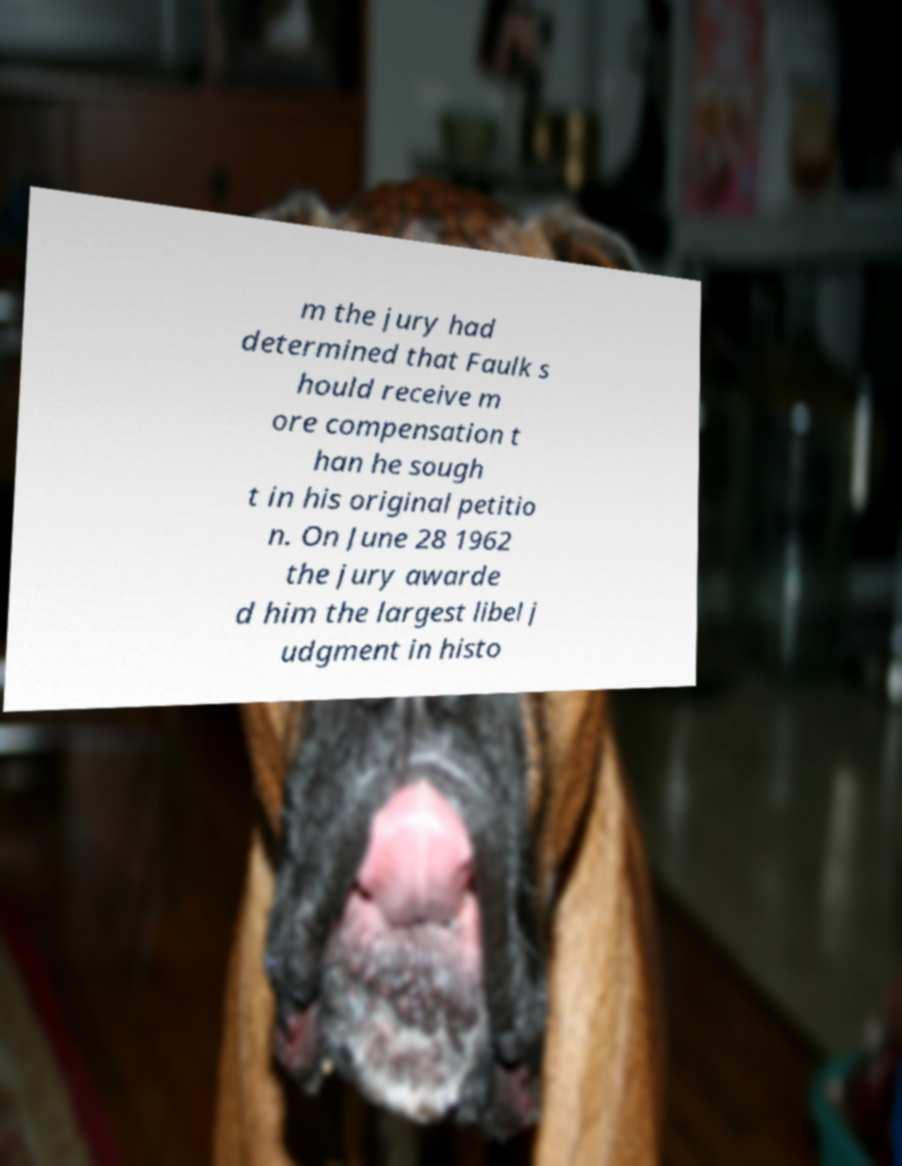Please read and relay the text visible in this image. What does it say? m the jury had determined that Faulk s hould receive m ore compensation t han he sough t in his original petitio n. On June 28 1962 the jury awarde d him the largest libel j udgment in histo 